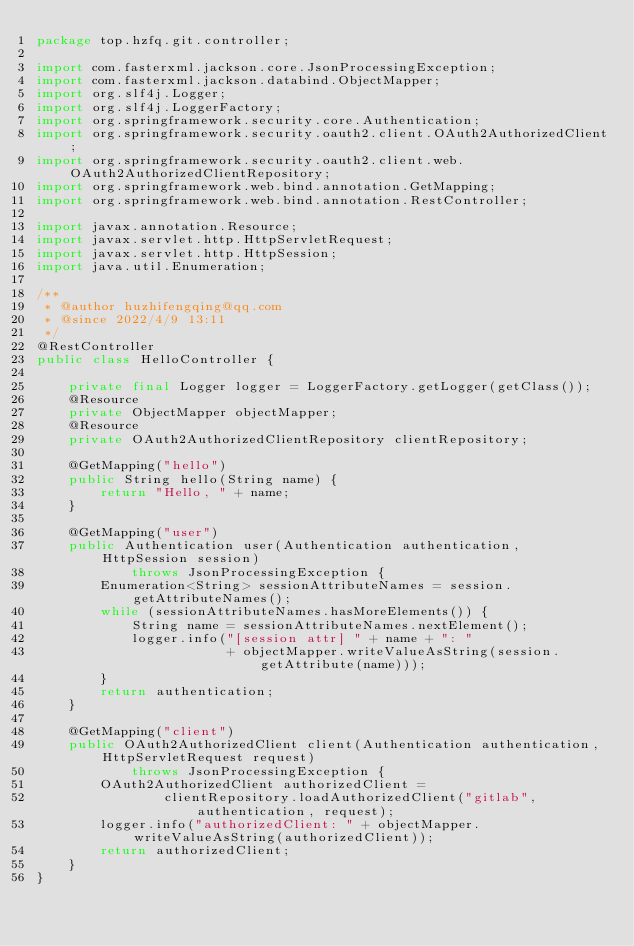<code> <loc_0><loc_0><loc_500><loc_500><_Java_>package top.hzfq.git.controller;

import com.fasterxml.jackson.core.JsonProcessingException;
import com.fasterxml.jackson.databind.ObjectMapper;
import org.slf4j.Logger;
import org.slf4j.LoggerFactory;
import org.springframework.security.core.Authentication;
import org.springframework.security.oauth2.client.OAuth2AuthorizedClient;
import org.springframework.security.oauth2.client.web.OAuth2AuthorizedClientRepository;
import org.springframework.web.bind.annotation.GetMapping;
import org.springframework.web.bind.annotation.RestController;

import javax.annotation.Resource;
import javax.servlet.http.HttpServletRequest;
import javax.servlet.http.HttpSession;
import java.util.Enumeration;

/**
 * @author huzhifengqing@qq.com
 * @since 2022/4/9 13:11
 */
@RestController
public class HelloController {

    private final Logger logger = LoggerFactory.getLogger(getClass());
    @Resource
    private ObjectMapper objectMapper;
    @Resource
    private OAuth2AuthorizedClientRepository clientRepository;

    @GetMapping("hello")
    public String hello(String name) {
        return "Hello, " + name;
    }

    @GetMapping("user")
    public Authentication user(Authentication authentication, HttpSession session)
            throws JsonProcessingException {
        Enumeration<String> sessionAttributeNames = session.getAttributeNames();
        while (sessionAttributeNames.hasMoreElements()) {
            String name = sessionAttributeNames.nextElement();
            logger.info("[session attr] " + name + ": "
                        + objectMapper.writeValueAsString(session.getAttribute(name)));
        }
        return authentication;
    }

    @GetMapping("client")
    public OAuth2AuthorizedClient client(Authentication authentication, HttpServletRequest request)
            throws JsonProcessingException {
        OAuth2AuthorizedClient authorizedClient =
                clientRepository.loadAuthorizedClient("gitlab", authentication, request);
        logger.info("authorizedClient: " + objectMapper.writeValueAsString(authorizedClient));
        return authorizedClient;
    }
}
</code> 